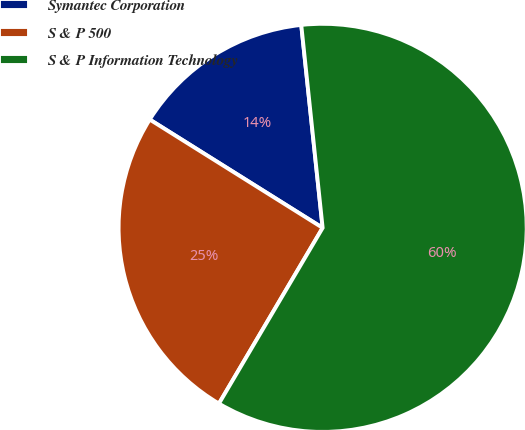Convert chart. <chart><loc_0><loc_0><loc_500><loc_500><pie_chart><fcel>Symantec Corporation<fcel>S & P 500<fcel>S & P Information Technology<nl><fcel>14.42%<fcel>25.42%<fcel>60.15%<nl></chart> 